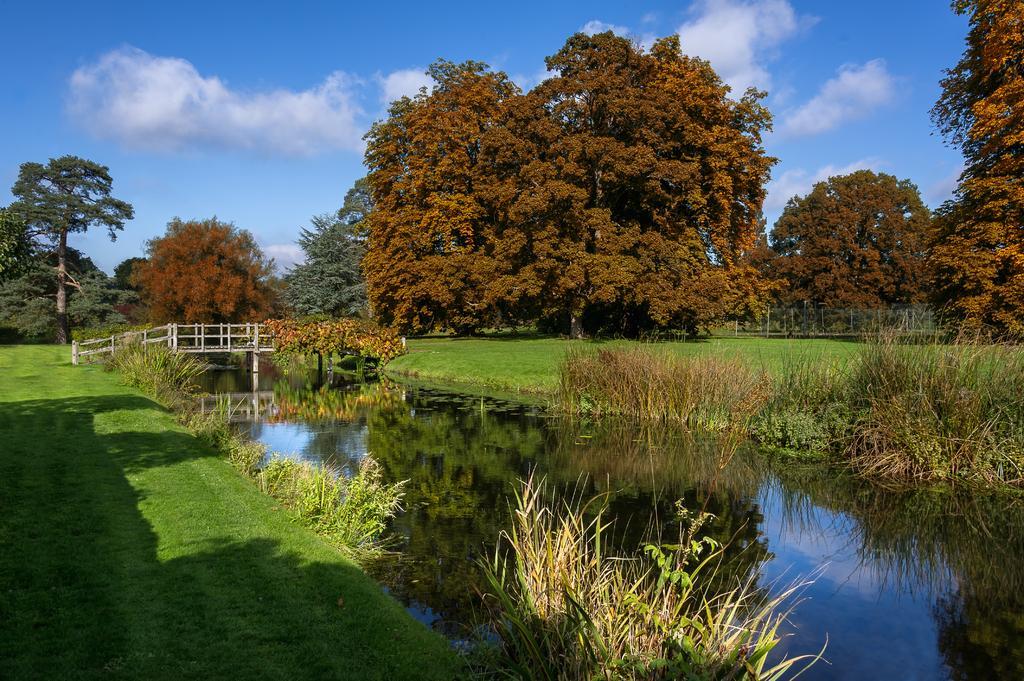Please provide a concise description of this image. In this picture we can see grass, water, bridge, trees and a sky. 